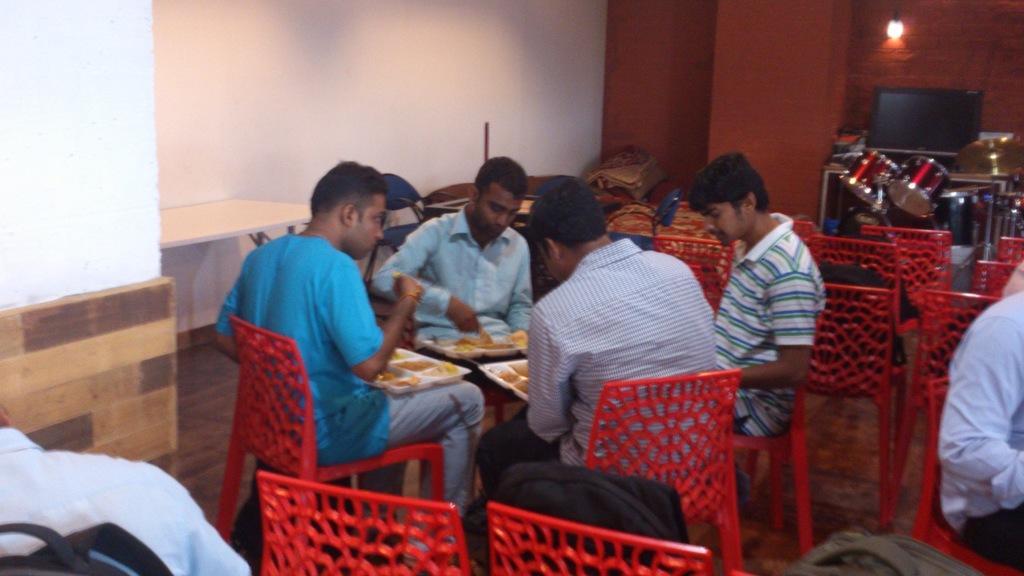Please provide a concise description of this image. In this picture, we can see a group of people sitting on chairs and holding the plates and behind the people there are chairs, drums, cymbal and a wall with a light. 